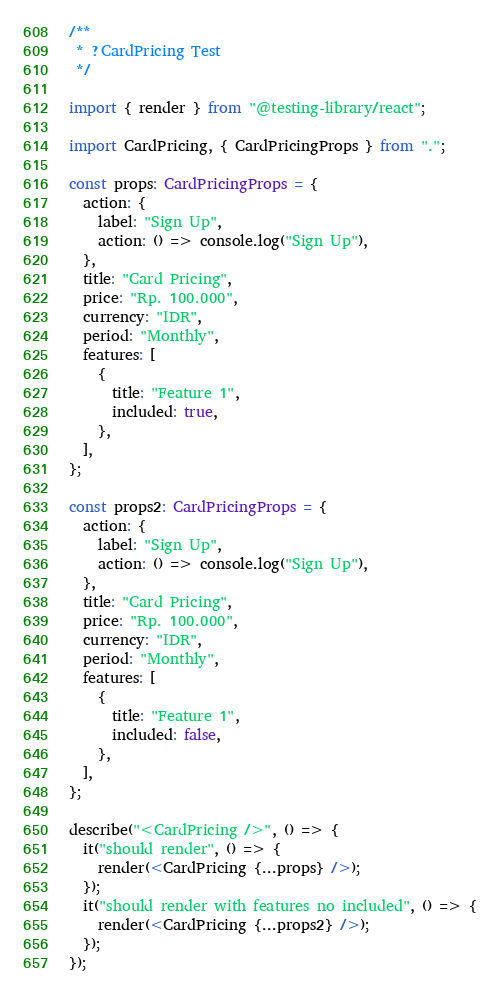<code> <loc_0><loc_0><loc_500><loc_500><_TypeScript_>/**
 * ?CardPricing Test
 */

import { render } from "@testing-library/react";

import CardPricing, { CardPricingProps } from ".";

const props: CardPricingProps = {
  action: {
    label: "Sign Up",
    action: () => console.log("Sign Up"),
  },
  title: "Card Pricing",
  price: "Rp. 100.000",
  currency: "IDR",
  period: "Monthly",
  features: [
    {
      title: "Feature 1",
      included: true,
    },
  ],
};

const props2: CardPricingProps = {
  action: {
    label: "Sign Up",
    action: () => console.log("Sign Up"),
  },
  title: "Card Pricing",
  price: "Rp. 100.000",
  currency: "IDR",
  period: "Monthly",
  features: [
    {
      title: "Feature 1",
      included: false,
    },
  ],
};

describe("<CardPricing />", () => {
  it("should render", () => {
    render(<CardPricing {...props} />);
  });
  it("should render with features no included", () => {
    render(<CardPricing {...props2} />);
  });
});
</code> 